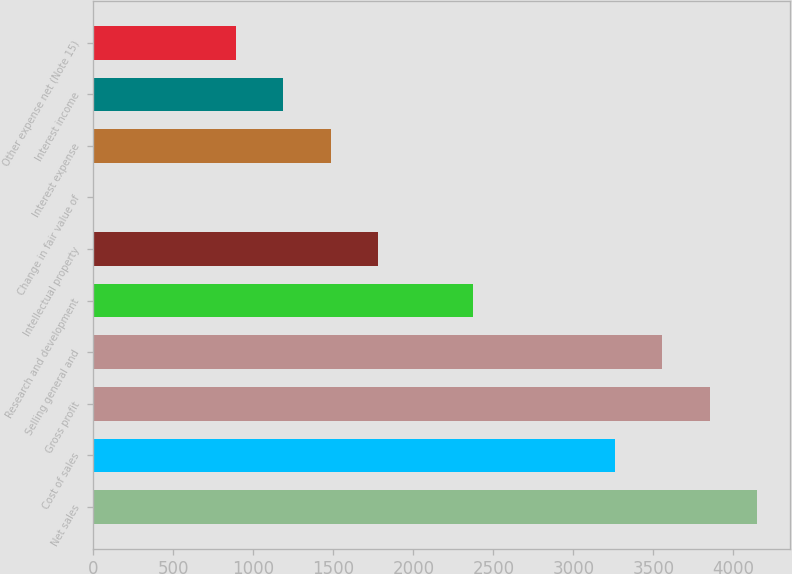Convert chart. <chart><loc_0><loc_0><loc_500><loc_500><bar_chart><fcel>Net sales<fcel>Cost of sales<fcel>Gross profit<fcel>Selling general and<fcel>Research and development<fcel>Intellectual property<fcel>Change in fair value of<fcel>Interest expense<fcel>Interest income<fcel>Other expense net (Note 15)<nl><fcel>4148.74<fcel>3259.96<fcel>3852.48<fcel>3556.22<fcel>2371.18<fcel>1778.66<fcel>1.1<fcel>1482.4<fcel>1186.14<fcel>889.88<nl></chart> 